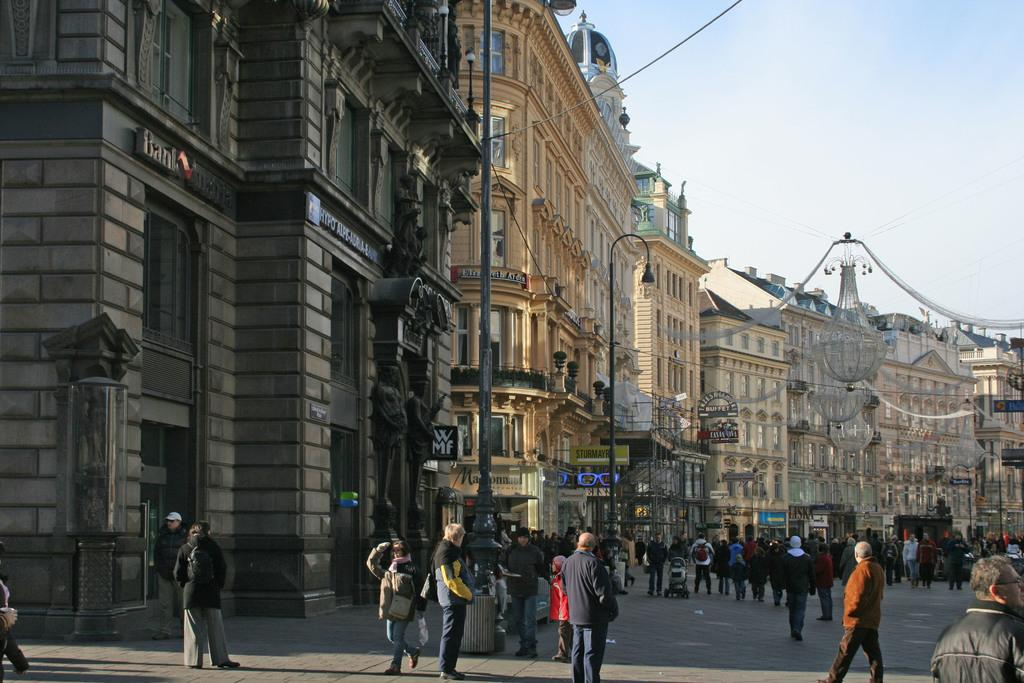What are the people in the image doing? The people in the image are walking on the road. What can be seen in the background of the image? There are buildings visible in the image. What type of pest can be seen crawling on the buildings in the image? There are no pests visible in the image; the image only shows people walking on the road and buildings in the background. 